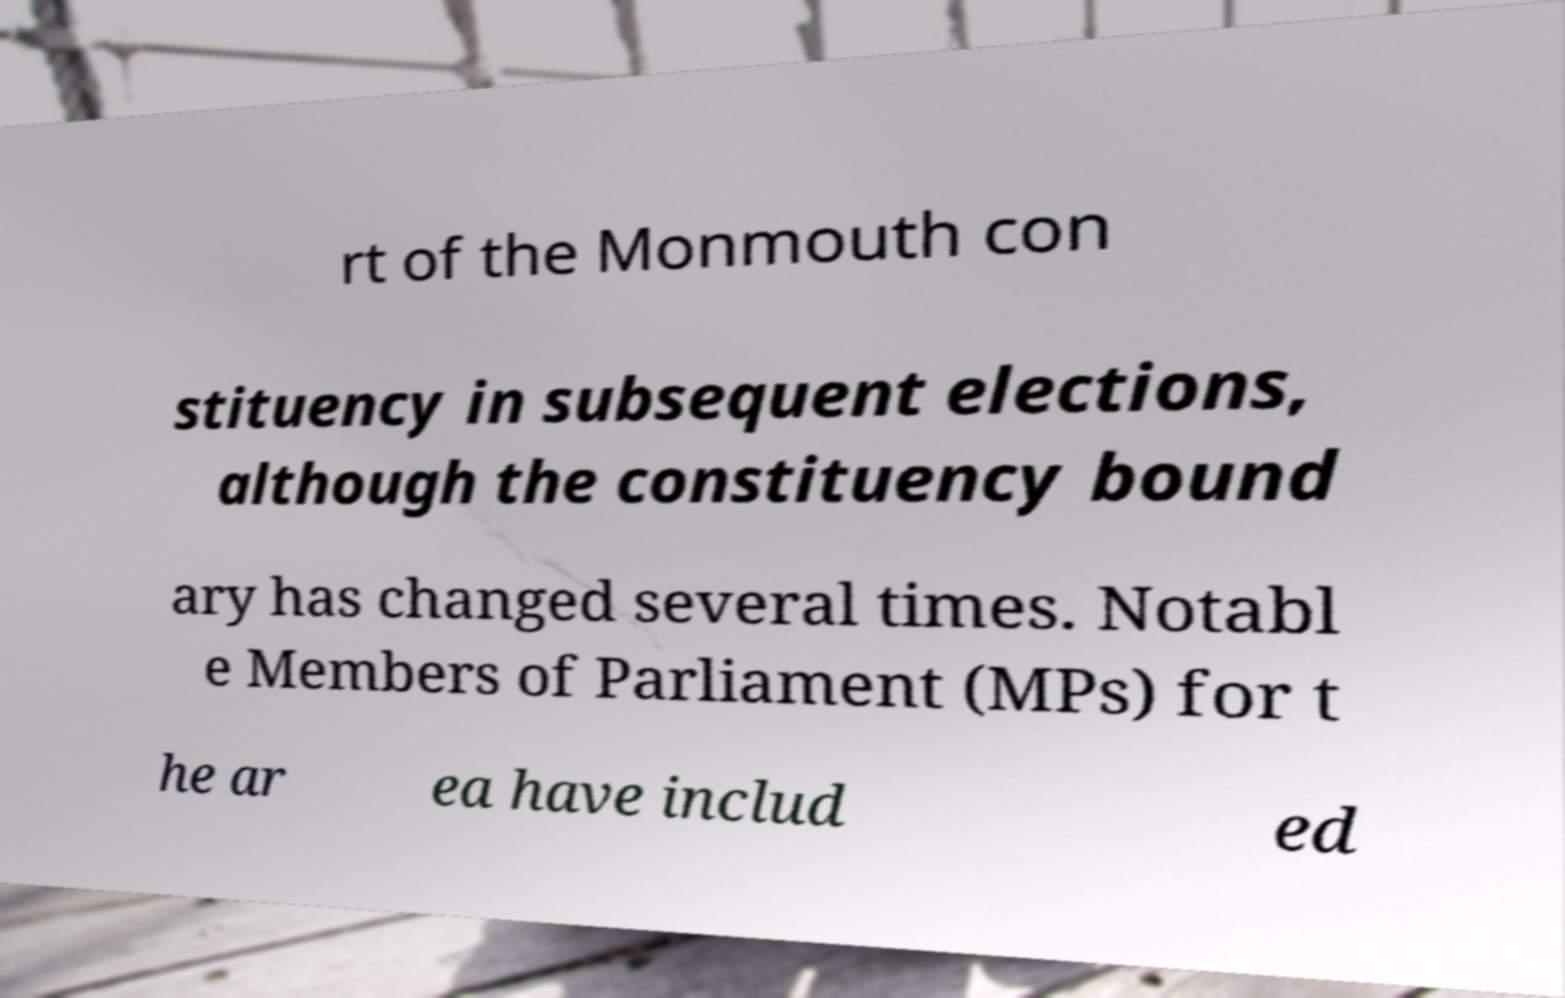What messages or text are displayed in this image? I need them in a readable, typed format. rt of the Monmouth con stituency in subsequent elections, although the constituency bound ary has changed several times. Notabl e Members of Parliament (MPs) for t he ar ea have includ ed 